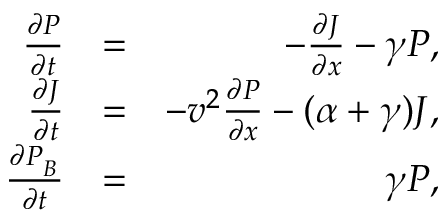Convert formula to latex. <formula><loc_0><loc_0><loc_500><loc_500>\begin{array} { r l r } { \frac { \partial P } { \partial t } } & { = } & { - \frac { \partial J } { \partial x } - \gamma P , } \\ { \frac { \partial J } { \partial t } } & { = } & { - v ^ { 2 } \frac { \partial P } { \partial x } - ( \alpha + \gamma ) J , } \\ { \frac { \partial P _ { _ { B } } } { \partial t } } & { = } & { \gamma P , } \end{array}</formula> 